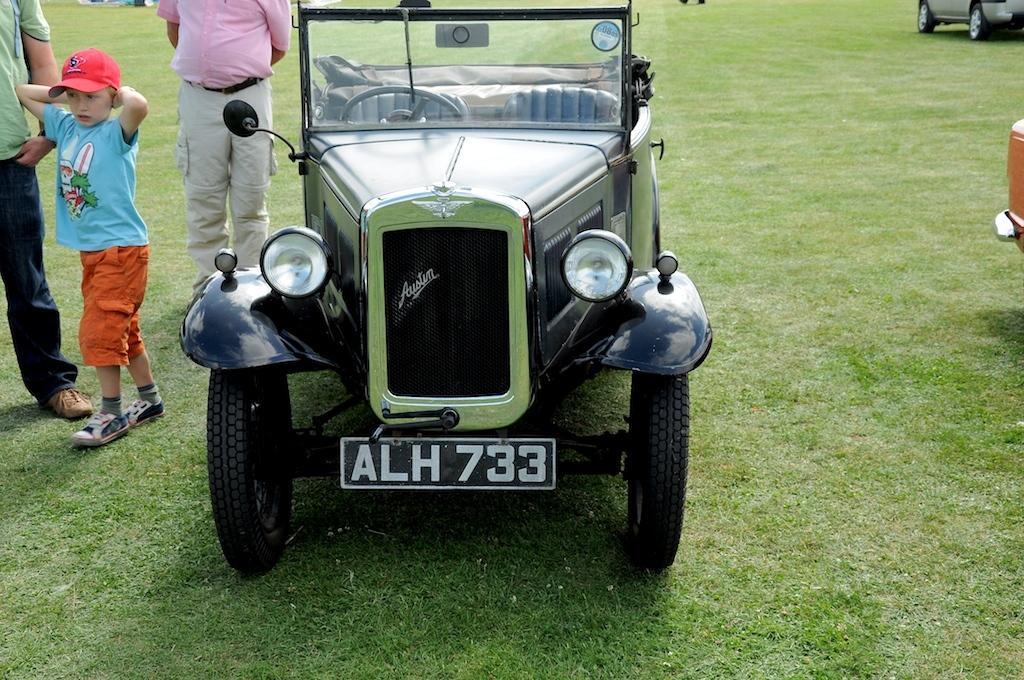Please provide a concise description of this image. In this image I can see an open grass ground and on it I can see three vehicles. On the left side of this image I can see a boy and two men are standing. I can also see the boy is wearing a red cap and on the bottom side I can see something is written on the vehicle. 